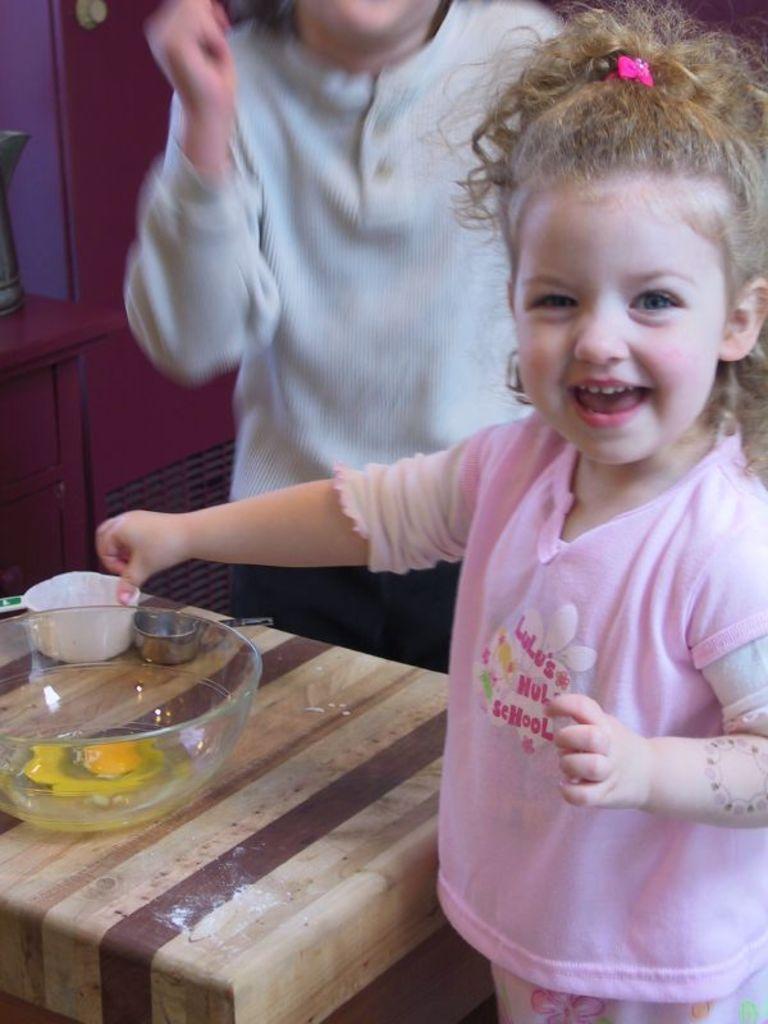Could you give a brief overview of what you see in this image? In this image i can see a girl standing, wearing a pink dress. In front of her i can see a table with a bowl on it. In the background i can see a person standing, a wall and a table. 